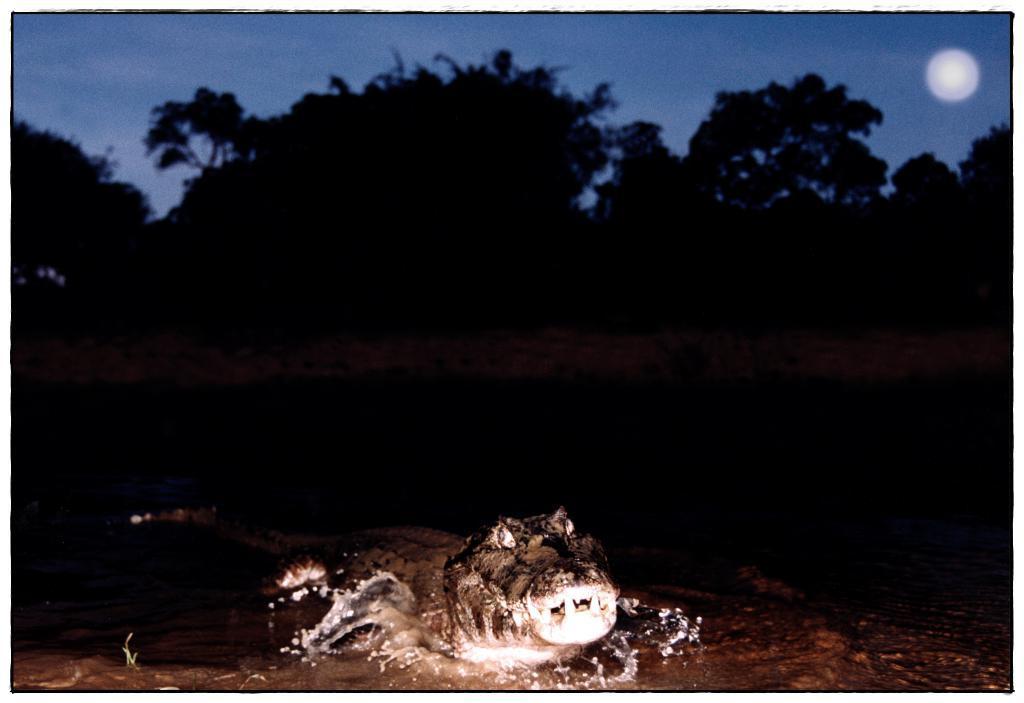Can you describe this image briefly? In the image in the center, we can see one crocodile in the water. In the background, we can see the sky, trees and the moon. 